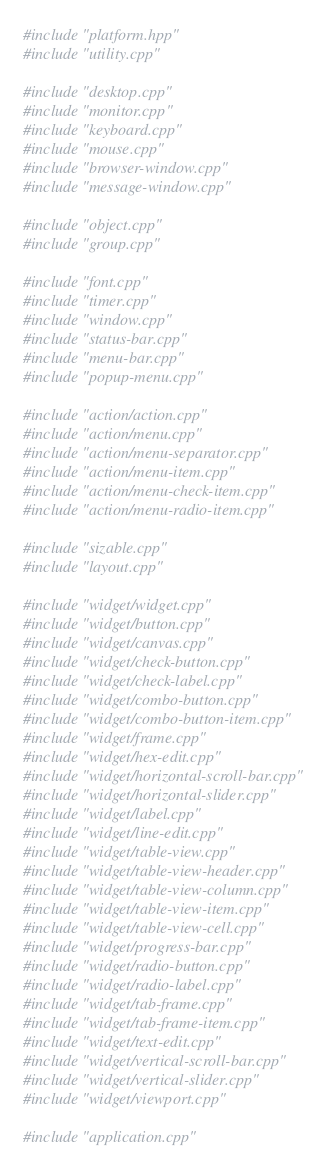<code> <loc_0><loc_0><loc_500><loc_500><_C++_>#include "platform.hpp"
#include "utility.cpp"

#include "desktop.cpp"
#include "monitor.cpp"
#include "keyboard.cpp"
#include "mouse.cpp"
#include "browser-window.cpp"
#include "message-window.cpp"

#include "object.cpp"
#include "group.cpp"

#include "font.cpp"
#include "timer.cpp"
#include "window.cpp"
#include "status-bar.cpp"
#include "menu-bar.cpp"
#include "popup-menu.cpp"

#include "action/action.cpp"
#include "action/menu.cpp"
#include "action/menu-separator.cpp"
#include "action/menu-item.cpp"
#include "action/menu-check-item.cpp"
#include "action/menu-radio-item.cpp"

#include "sizable.cpp"
#include "layout.cpp"

#include "widget/widget.cpp"
#include "widget/button.cpp"
#include "widget/canvas.cpp"
#include "widget/check-button.cpp"
#include "widget/check-label.cpp"
#include "widget/combo-button.cpp"
#include "widget/combo-button-item.cpp"
#include "widget/frame.cpp"
#include "widget/hex-edit.cpp"
#include "widget/horizontal-scroll-bar.cpp"
#include "widget/horizontal-slider.cpp"
#include "widget/label.cpp"
#include "widget/line-edit.cpp"
#include "widget/table-view.cpp"
#include "widget/table-view-header.cpp"
#include "widget/table-view-column.cpp"
#include "widget/table-view-item.cpp"
#include "widget/table-view-cell.cpp"
#include "widget/progress-bar.cpp"
#include "widget/radio-button.cpp"
#include "widget/radio-label.cpp"
#include "widget/tab-frame.cpp"
#include "widget/tab-frame-item.cpp"
#include "widget/text-edit.cpp"
#include "widget/vertical-scroll-bar.cpp"
#include "widget/vertical-slider.cpp"
#include "widget/viewport.cpp"

#include "application.cpp"
</code> 